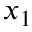Convert formula to latex. <formula><loc_0><loc_0><loc_500><loc_500>x _ { 1 }</formula> 